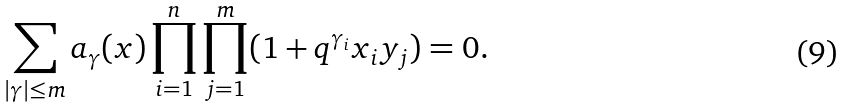Convert formula to latex. <formula><loc_0><loc_0><loc_500><loc_500>\sum _ { | \gamma | \leq m } a _ { \gamma } ( x ) \prod _ { i = 1 } ^ { n } \prod _ { j = 1 } ^ { m } ( 1 + q ^ { \gamma _ { i } } x _ { i } y _ { j } ) = 0 .</formula> 